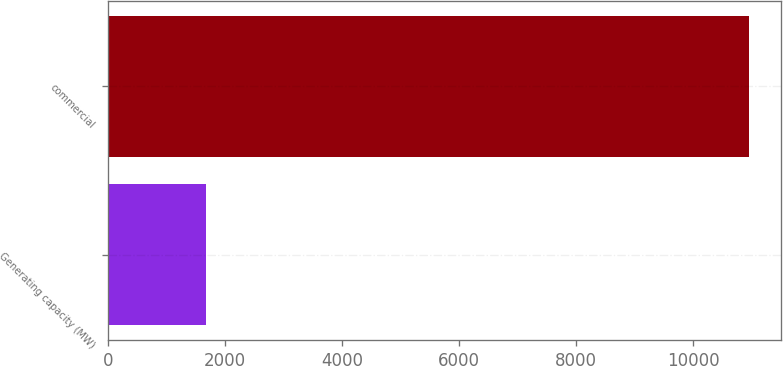Convert chart to OTSL. <chart><loc_0><loc_0><loc_500><loc_500><bar_chart><fcel>Generating capacity (MW)<fcel>commercial<nl><fcel>1668<fcel>10957<nl></chart> 